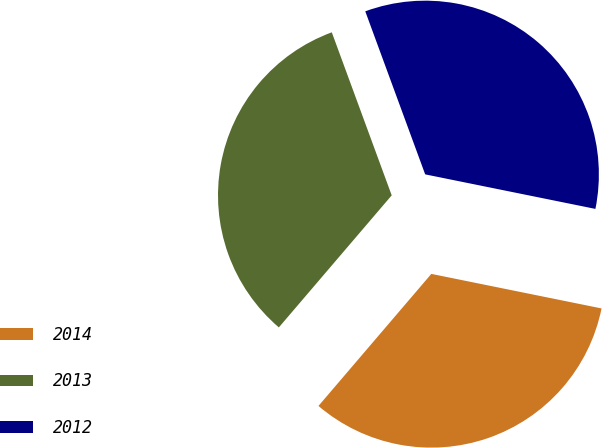<chart> <loc_0><loc_0><loc_500><loc_500><pie_chart><fcel>2014<fcel>2013<fcel>2012<nl><fcel>33.07%<fcel>33.14%<fcel>33.79%<nl></chart> 